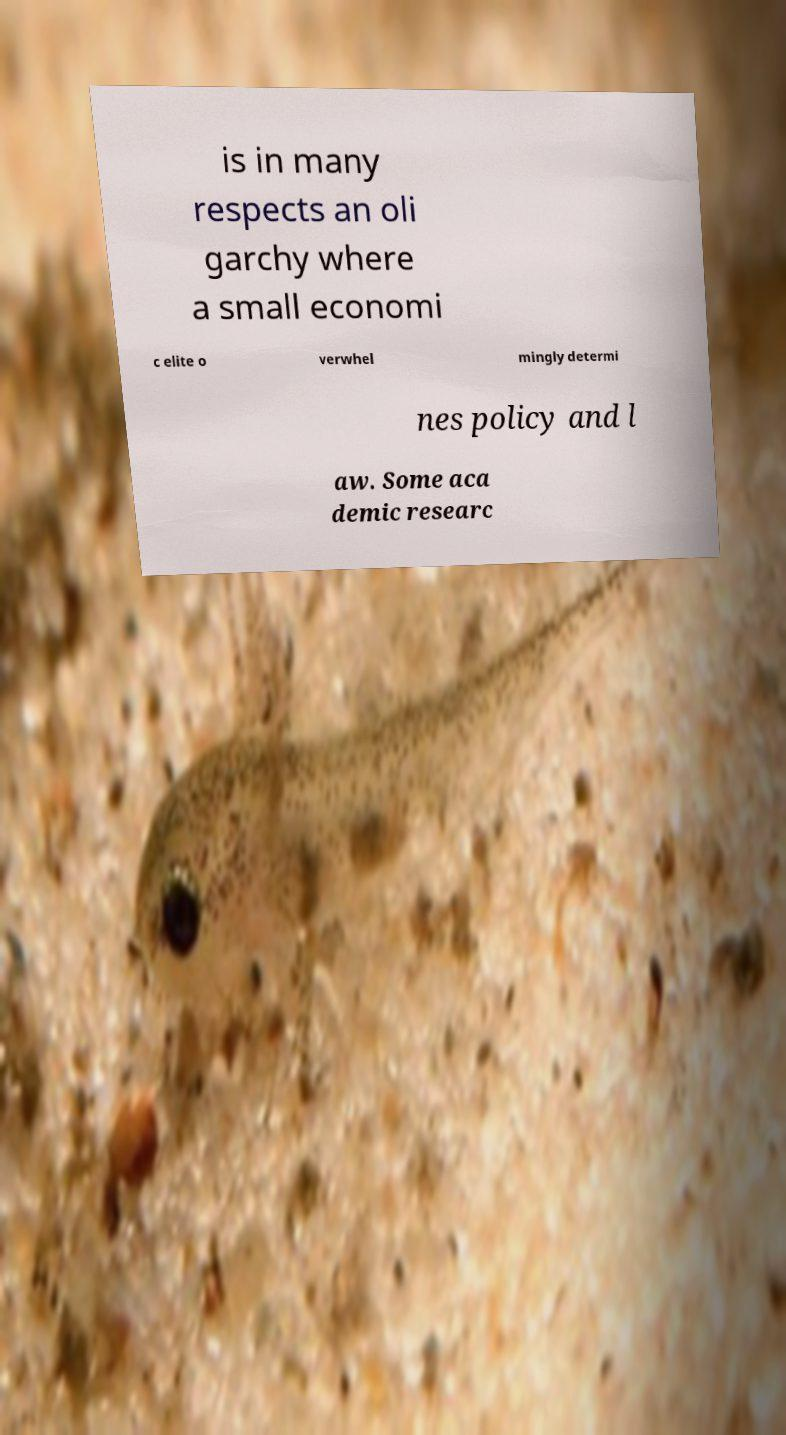Could you extract and type out the text from this image? is in many respects an oli garchy where a small economi c elite o verwhel mingly determi nes policy and l aw. Some aca demic researc 